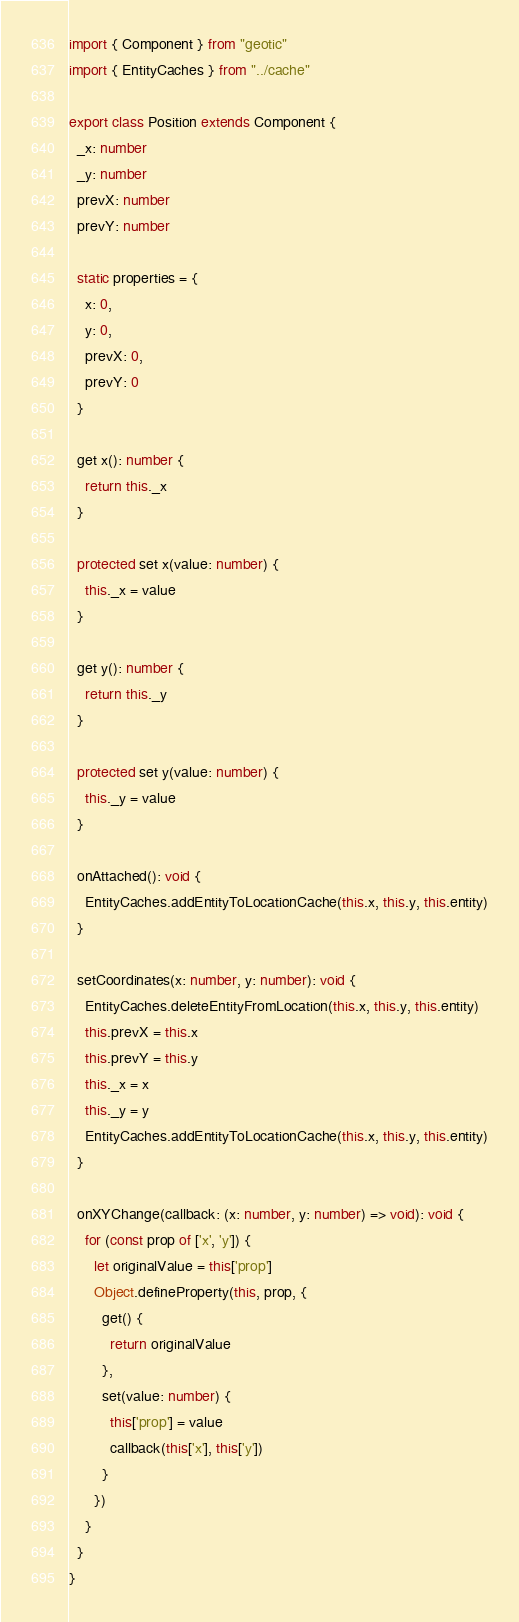Convert code to text. <code><loc_0><loc_0><loc_500><loc_500><_TypeScript_>import { Component } from "geotic"
import { EntityCaches } from "../cache"

export class Position extends Component {
  _x: number
  _y: number
  prevX: number
  prevY: number

  static properties = {
    x: 0,
    y: 0,
    prevX: 0,
    prevY: 0
  }

  get x(): number {
    return this._x
  }

  protected set x(value: number) {
    this._x = value
  }

  get y(): number {
    return this._y
  }

  protected set y(value: number) {
    this._y = value
  }

  onAttached(): void {
    EntityCaches.addEntityToLocationCache(this.x, this.y, this.entity)
  }

  setCoordinates(x: number, y: number): void {
    EntityCaches.deleteEntityFromLocation(this.x, this.y, this.entity)
    this.prevX = this.x
    this.prevY = this.y
    this._x = x
    this._y = y
    EntityCaches.addEntityToLocationCache(this.x, this.y, this.entity)
  }

  onXYChange(callback: (x: number, y: number) => void): void {
    for (const prop of ['x', 'y']) {
      let originalValue = this['prop']
      Object.defineProperty(this, prop, {
        get() {
          return originalValue
        },
        set(value: number) {
          this['prop'] = value
          callback(this['x'], this['y'])
        }
      })
    }
  }
}</code> 